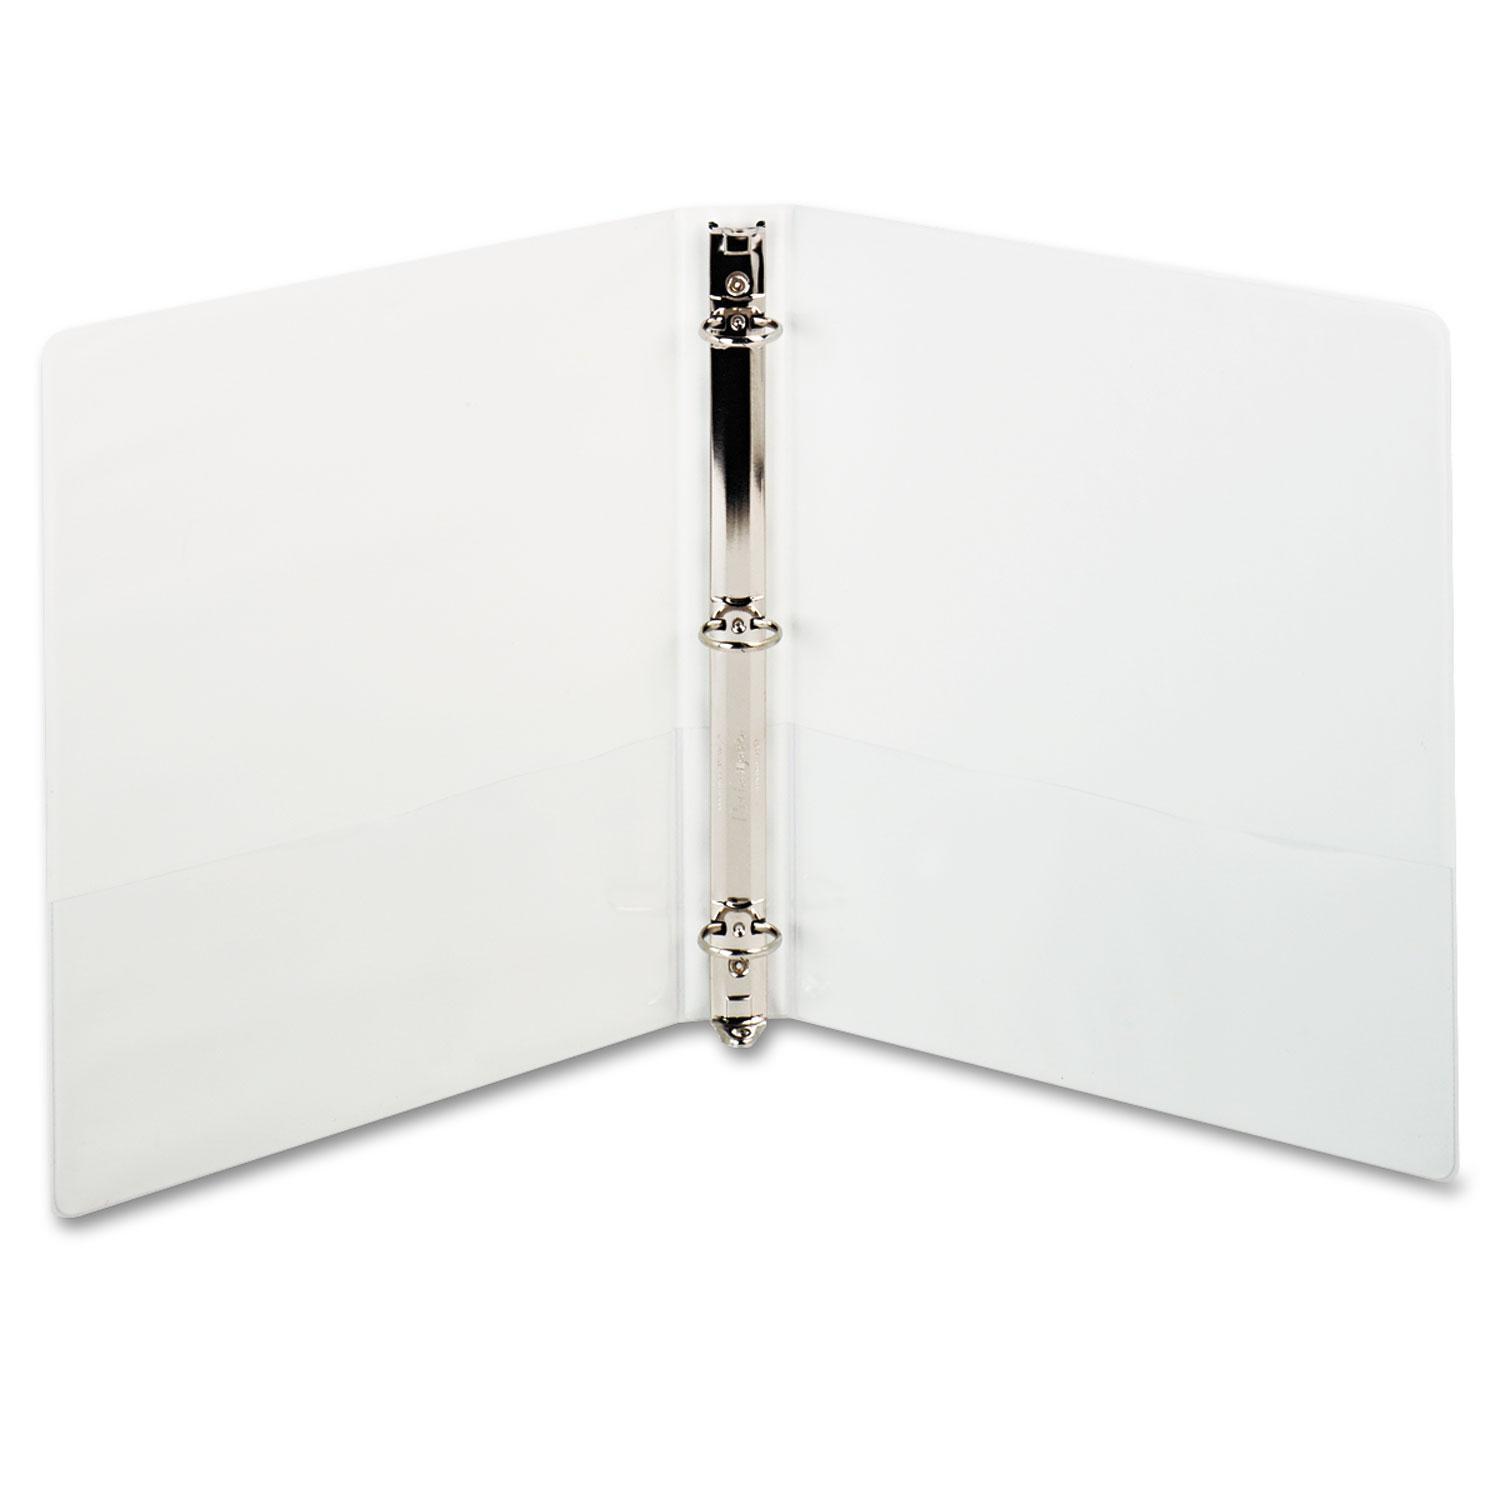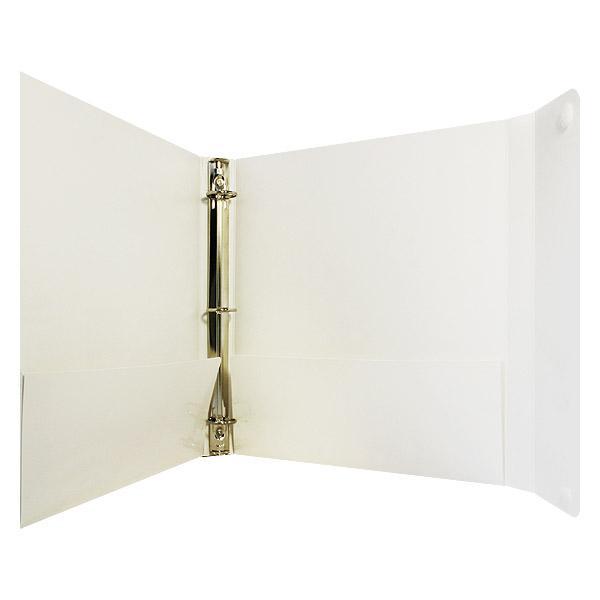The first image is the image on the left, the second image is the image on the right. Analyze the images presented: Is the assertion "One image includes at least one closed, upright binder next to an open upright binder, and the combined images contain at least some non-white binders." valid? Answer yes or no. No. The first image is the image on the left, the second image is the image on the right. Considering the images on both sides, is "There are no more than two binders shown." valid? Answer yes or no. Yes. 